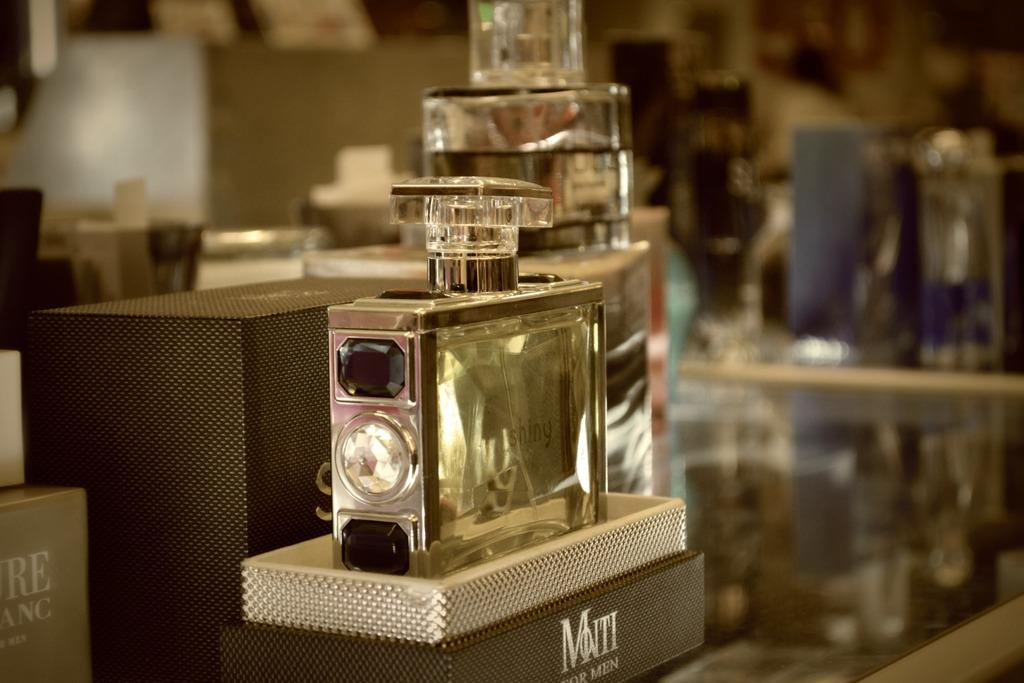What is there is a table in the center of the image, what is on it? Perfume bottles are present on the table. What can be seen behind the table in the image? There is a wall in the background of the image. Are there any other objects visible in the background? Yes, there are other objects visible in the background of the image. What type of sock is hanging on the wall in the image? There is no sock present in the image; it only features perfume bottles on a table and a wall in the background. 